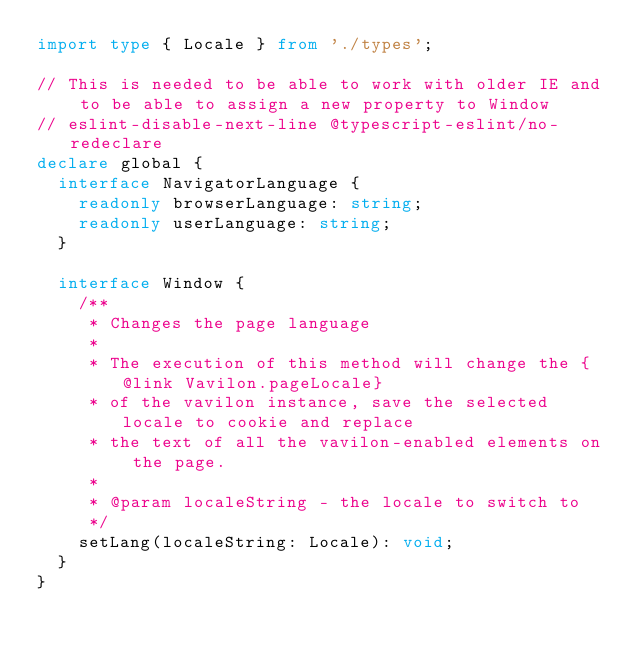Convert code to text. <code><loc_0><loc_0><loc_500><loc_500><_TypeScript_>import type { Locale } from './types';

// This is needed to be able to work with older IE and to be able to assign a new property to Window
// eslint-disable-next-line @typescript-eslint/no-redeclare
declare global {
  interface NavigatorLanguage {
    readonly browserLanguage: string;
    readonly userLanguage: string;
  }

  interface Window {
    /**
     * Changes the page language
     *
     * The execution of this method will change the {@link Vavilon.pageLocale}
     * of the vavilon instance, save the selected locale to cookie and replace
     * the text of all the vavilon-enabled elements on the page.
     *
     * @param localeString - the locale to switch to
     */
    setLang(localeString: Locale): void;
  }
}
</code> 